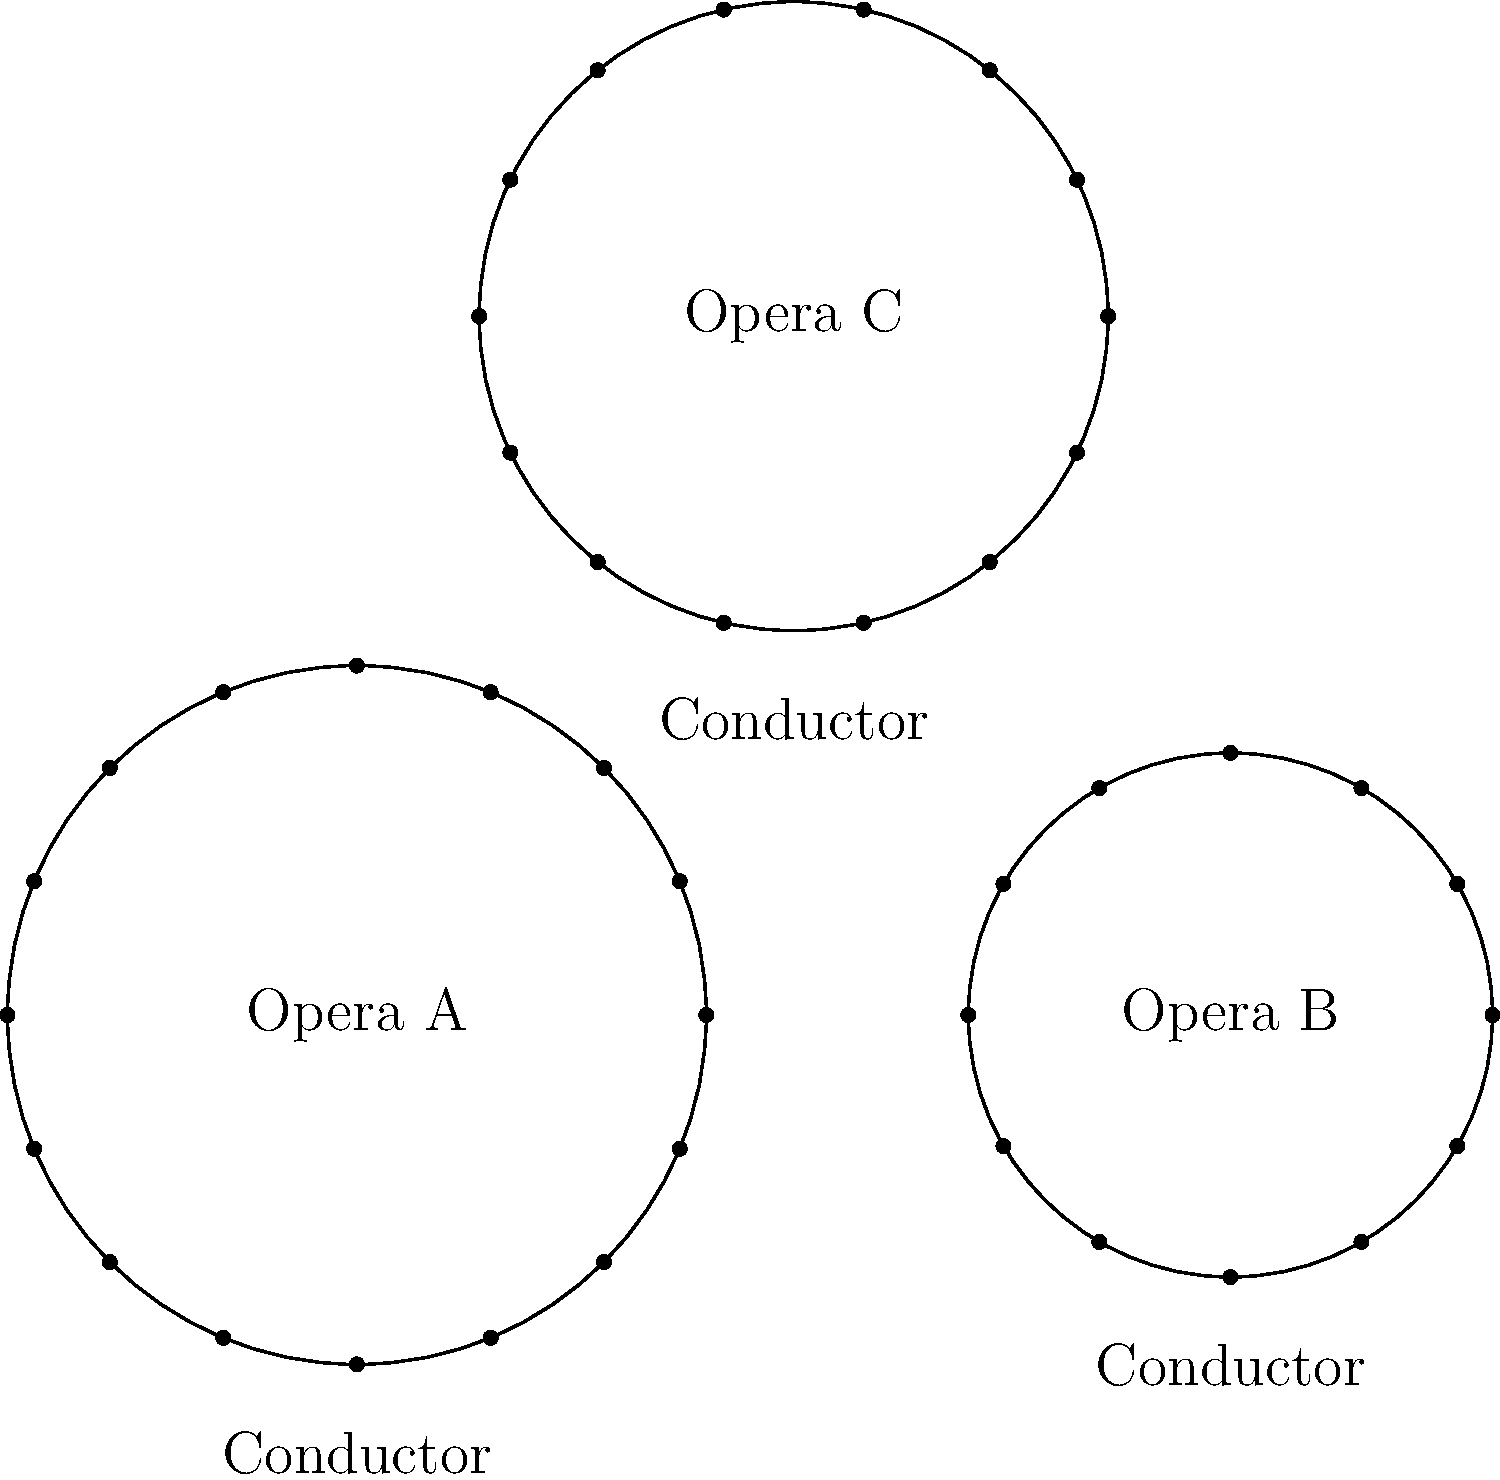Analyze the floor plans of three opera orchestras (A, B, and C) shown above. Which orchestra arrangement allows for the most intimate connection between the conductor and the musicians, potentially enhancing the maestro's influence on the performance? To determine which orchestra arrangement allows for the most intimate connection between the conductor and the musicians, we need to consider several factors:

1. Size of the orchestra:
   Opera A: 16 musicians
   Opera B: 12 musicians
   Opera C: 14 musicians

2. Radius of the seating arrangement:
   Opera A: Largest radius
   Opera B: Smallest radius
   Opera C: Medium radius

3. Distance between conductor and musicians:
   Opera A: Largest distance
   Opera B: Smallest distance
   Opera C: Medium distance

4. Compactness of the arrangement:
   Opera B appears to be the most compact, followed by Opera C, then Opera A.

The most intimate connection between the conductor and musicians is likely to occur in the arrangement where:
a) The number of musicians is smaller
b) The radius of the seating arrangement is smaller
c) The distance between the conductor and musicians is shorter
d) The overall arrangement is more compact

Based on these criteria, Opera B provides the most intimate setting:
- It has the fewest musicians (12)
- The smallest radius
- The shortest distance between conductor and musicians
- The most compact arrangement

This setup allows for better eye contact, clearer gestures from the conductor, and potentially enhanced communication between the maestro and the orchestra members.
Answer: Opera B 